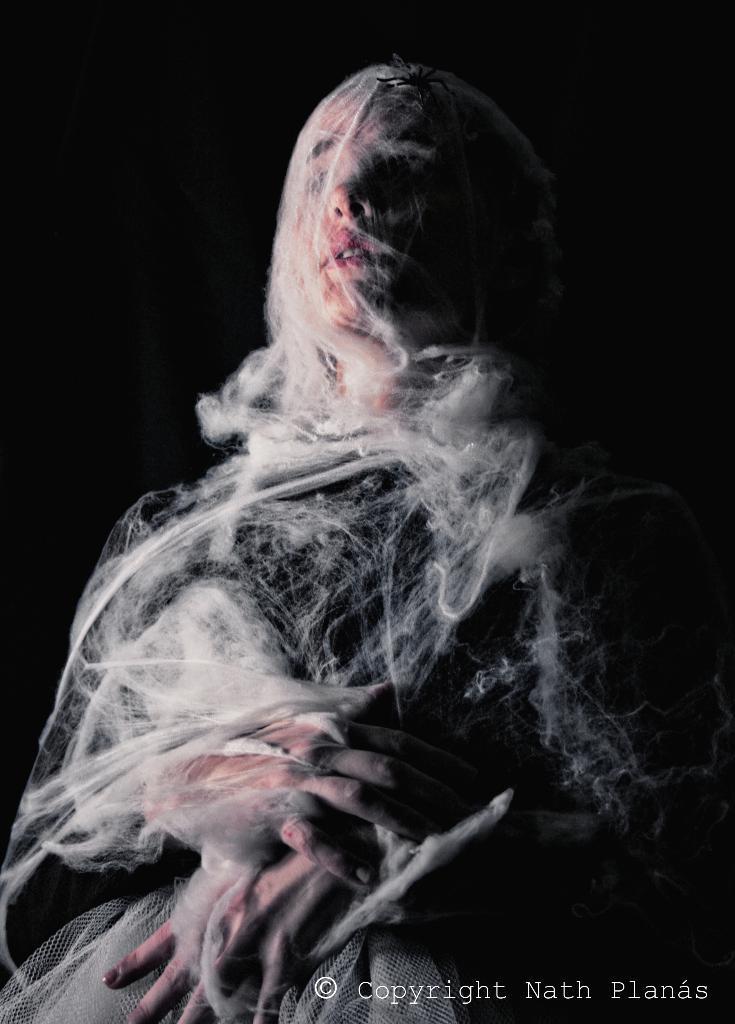Can you describe this image briefly? Background portion of the picture is completely dark. Here we can see a person and a white net wrapped around the body. At the bottom right corner of the image there is a water mark. 